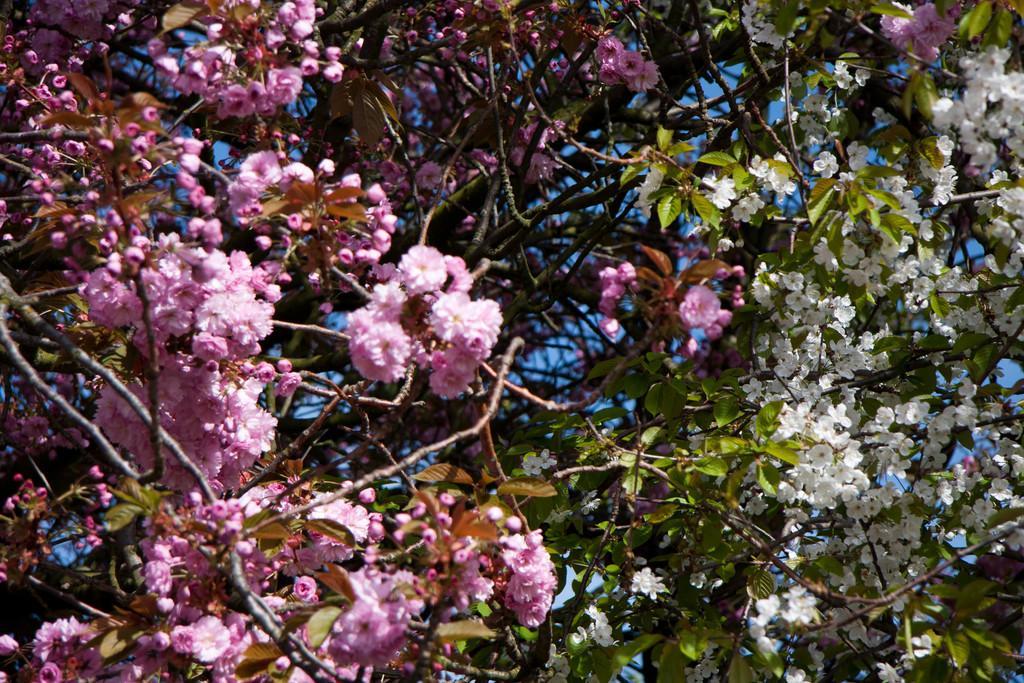In one or two sentences, can you explain what this image depicts? In this picture, we can see some trees with flowers some flowers are in pink color which are on the left side, some flowers are in white color which are on the right side. In the background, there is a sky. 